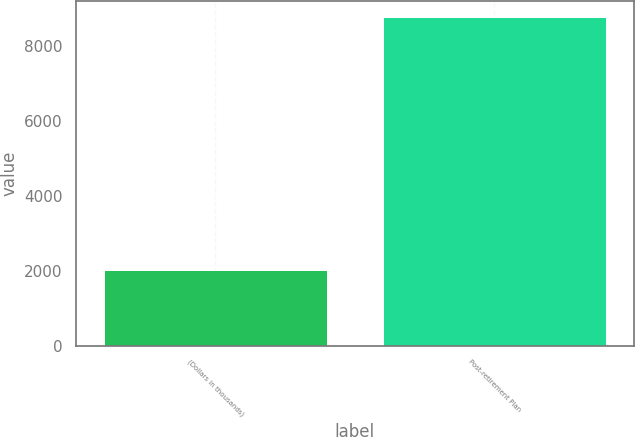<chart> <loc_0><loc_0><loc_500><loc_500><bar_chart><fcel>(Dollars in thousands)<fcel>Post-retirement Plan<nl><fcel>2006<fcel>8780<nl></chart> 